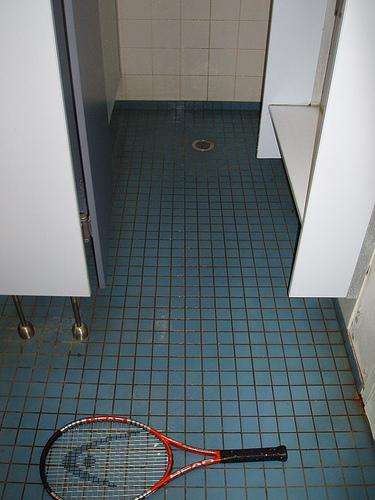What brand is the tennis racket?
Short answer required. Wilson. How many tennis rackets are there?
Write a very short answer. 1. What color is the floor?
Write a very short answer. Blue. What room is the tennis racket in?
Quick response, please. Bathroom. How many tiles are on the floor?
Concise answer only. Many. 